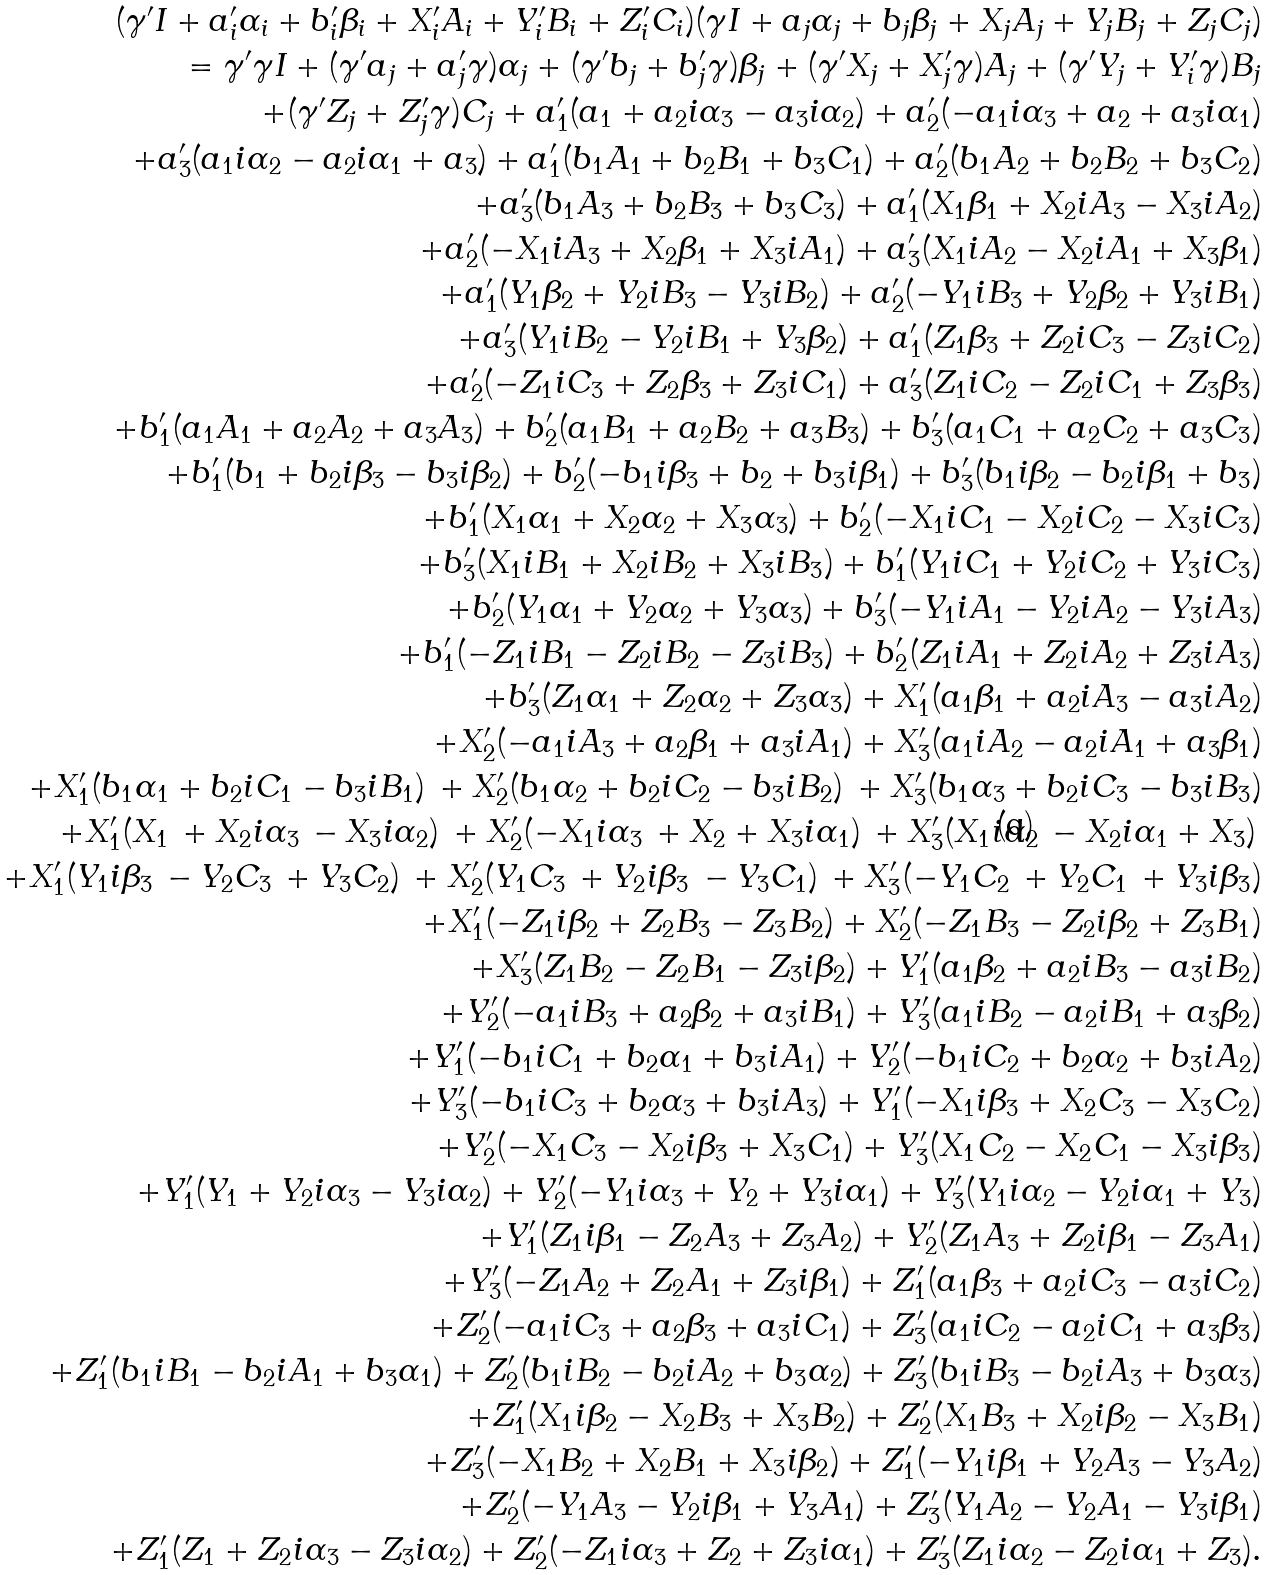Convert formula to latex. <formula><loc_0><loc_0><loc_500><loc_500>( \gamma ^ { \prime } I + a _ { i } ^ { \prime } \alpha _ { i } + b _ { i } ^ { \prime } \beta _ { i } + X _ { i } ^ { \prime } A _ { i } + Y _ { i } ^ { \prime } B _ { i } + Z _ { i } ^ { \prime } C _ { i } ) ( \gamma I + a _ { j } \alpha _ { j } + b _ { j } \beta _ { j } + X _ { j } A _ { j } + Y _ { j } B _ { j } + Z _ { j } C _ { j } ) \\ = \gamma ^ { \prime } \gamma I + ( \gamma ^ { \prime } a _ { j } + a _ { j } ^ { \prime } \gamma ) \alpha _ { j } + ( \gamma ^ { \prime } b _ { j } + b _ { j } ^ { \prime } \gamma ) \beta _ { j } + ( \gamma ^ { \prime } X _ { j } + X _ { j } ^ { \prime } \gamma ) A _ { j } + ( \gamma ^ { \prime } Y _ { j } + Y _ { i } ^ { \prime } \gamma ) B _ { j } \\ + ( \gamma ^ { \prime } Z _ { j } + Z _ { j } ^ { \prime } \gamma ) C _ { j } + a _ { 1 } ^ { \prime } ( a _ { 1 } + a _ { 2 } i \alpha _ { 3 } - a _ { 3 } i \alpha _ { 2 } ) + a _ { 2 } ^ { \prime } ( - a _ { 1 } i \alpha _ { 3 } + a _ { 2 } + a _ { 3 } i \alpha _ { 1 } ) \\ + a _ { 3 } ^ { \prime } ( a _ { 1 } i \alpha _ { 2 } - a _ { 2 } i \alpha _ { 1 } + a _ { 3 } ) + a _ { 1 } ^ { \prime } ( b _ { 1 } A _ { 1 } + b _ { 2 } B _ { 1 } + b _ { 3 } C _ { 1 } ) + a _ { 2 } ^ { \prime } ( b _ { 1 } A _ { 2 } + b _ { 2 } B _ { 2 } + b _ { 3 } C _ { 2 } ) \\ + a _ { 3 } ^ { \prime } ( b _ { 1 } A _ { 3 } + b _ { 2 } B _ { 3 } + b _ { 3 } C _ { 3 } ) + a _ { 1 } ^ { \prime } ( X _ { 1 } \beta _ { 1 } + X _ { 2 } i A _ { 3 } - X _ { 3 } i A _ { 2 } ) \\ + a _ { 2 } ^ { \prime } ( - X _ { 1 } i A _ { 3 } + X _ { 2 } \beta _ { 1 } + X _ { 3 } i A _ { 1 } ) + a _ { 3 } ^ { \prime } ( X _ { 1 } i A _ { 2 } - X _ { 2 } i A _ { 1 } + X _ { 3 } \beta _ { 1 } ) \\ + a _ { 1 } ^ { \prime } ( Y _ { 1 } \beta _ { 2 } + Y _ { 2 } i B _ { 3 } - Y _ { 3 } i B _ { 2 } ) + a _ { 2 } ^ { \prime } ( - Y _ { 1 } i B _ { 3 } + Y _ { 2 } \beta _ { 2 } + Y _ { 3 } i B _ { 1 } ) \\ + a _ { 3 } ^ { \prime } ( Y _ { 1 } i B _ { 2 } - Y _ { 2 } i B _ { 1 } + Y _ { 3 } \beta _ { 2 } ) + a _ { 1 } ^ { \prime } ( Z _ { 1 } \beta _ { 3 } + Z _ { 2 } i C _ { 3 } - Z _ { 3 } i C _ { 2 } ) \\ + a _ { 2 } ^ { \prime } ( - Z _ { 1 } i C _ { 3 } + Z _ { 2 } \beta _ { 3 } + Z _ { 3 } i C _ { 1 } ) + a _ { 3 } ^ { \prime } ( Z _ { 1 } i C _ { 2 } - Z _ { 2 } i C _ { 1 } + Z _ { 3 } \beta _ { 3 } ) \\ + b _ { 1 } ^ { \prime } ( a _ { 1 } A _ { 1 } + a _ { 2 } A _ { 2 } + a _ { 3 } A _ { 3 } ) + b _ { 2 } ^ { \prime } ( a _ { 1 } B _ { 1 } + a _ { 2 } B _ { 2 } + a _ { 3 } B _ { 3 } ) + b _ { 3 } ^ { \prime } ( a _ { 1 } C _ { 1 } + a _ { 2 } C _ { 2 } + a _ { 3 } C _ { 3 } ) \\ + b _ { 1 } ^ { \prime } ( b _ { 1 } + b _ { 2 } i \beta _ { 3 } - b _ { 3 } i \beta _ { 2 } ) + b _ { 2 } ^ { \prime } ( - b _ { 1 } i \beta _ { 3 } + b _ { 2 } + b _ { 3 } i \beta _ { 1 } ) + b _ { 3 } ^ { \prime } ( b _ { 1 } i \beta _ { 2 } - b _ { 2 } i \beta _ { 1 } + b _ { 3 } ) \\ + b _ { 1 } ^ { \prime } ( X _ { 1 } \alpha _ { 1 } + X _ { 2 } \alpha _ { 2 } + X _ { 3 } \alpha _ { 3 } ) + b _ { 2 } ^ { \prime } ( - X _ { 1 } i C _ { 1 } - X _ { 2 } i C _ { 2 } - X _ { 3 } i C _ { 3 } ) \\ + b _ { 3 } ^ { \prime } ( X _ { 1 } i B _ { 1 } + X _ { 2 } i B _ { 2 } + X _ { 3 } i B _ { 3 } ) + b _ { 1 } ^ { \prime } ( Y _ { 1 } i C _ { 1 } + Y _ { 2 } i C _ { 2 } + Y _ { 3 } i C _ { 3 } ) \\ + b _ { 2 } ^ { \prime } ( Y _ { 1 } \alpha _ { 1 } + Y _ { 2 } \alpha _ { 2 } + Y _ { 3 } \alpha _ { 3 } ) + b _ { 3 } ^ { \prime } ( - Y _ { 1 } i A _ { 1 } - Y _ { 2 } i A _ { 2 } - Y _ { 3 } i A _ { 3 } ) \\ + b _ { 1 } ^ { \prime } ( - Z _ { 1 } i B _ { 1 } - Z _ { 2 } i B _ { 2 } - Z _ { 3 } i B _ { 3 } ) + b _ { 2 } ^ { \prime } ( Z _ { 1 } i A _ { 1 } + Z _ { 2 } i A _ { 2 } + Z _ { 3 } i A _ { 3 } ) \\ + b _ { 3 } ^ { \prime } ( Z _ { 1 } \alpha _ { 1 } + Z _ { 2 } \alpha _ { 2 } + Z _ { 3 } \alpha _ { 3 } ) + X _ { 1 } ^ { \prime } ( a _ { 1 } \beta _ { 1 } + a _ { 2 } i A _ { 3 } - a _ { 3 } i A _ { 2 } ) \\ + X _ { 2 } ^ { \prime } ( - a _ { 1 } i A _ { 3 } + a _ { 2 } \beta _ { 1 } + a _ { 3 } i A _ { 1 } ) + X _ { 3 } ^ { \prime } ( a _ { 1 } i A _ { 2 } - a _ { 2 } i A _ { 1 } + a _ { 3 } \beta _ { 1 } ) \\ + X _ { 1 } ^ { \prime } ( b _ { 1 } \alpha _ { 1 } + b _ { 2 } i C _ { 1 } - b _ { 3 } i B _ { 1 } ) \, + X _ { 2 } ^ { \prime } ( b _ { 1 } \alpha _ { 2 } + b _ { 2 } i C _ { 2 } - b _ { 3 } i B _ { 2 } ) \, + X _ { 3 } ^ { \prime } ( b _ { 1 } \alpha _ { 3 } + b _ { 2 } i C _ { 3 } - b _ { 3 } i B _ { 3 } ) \\ + X _ { 1 } ^ { \prime } ( X _ { 1 } \, + X _ { 2 } i \alpha _ { 3 } \, - X _ { 3 } i \alpha _ { 2 } ) \, + X _ { 2 } ^ { \prime } ( - X _ { 1 } i \alpha _ { 3 } \, + X _ { 2 } + X _ { 3 } i \alpha _ { 1 } ) \, + X _ { 3 } ^ { \prime } ( X _ { 1 } i \alpha _ { 2 } \, - X _ { 2 } i \alpha _ { 1 } + X _ { 3 } ) \, \\ + X _ { 1 } ^ { \prime } ( Y _ { 1 } i \beta _ { 3 } \, - Y _ { 2 } C _ { 3 } \, + Y _ { 3 } C _ { 2 } ) \, + X _ { 2 } ^ { \prime } ( Y _ { 1 } C _ { 3 } \, + Y _ { 2 } i \beta _ { 3 } \, - Y _ { 3 } C _ { 1 } ) \, + X _ { 3 } ^ { \prime } ( - Y _ { 1 } C _ { 2 } \, + Y _ { 2 } C _ { 1 } \, + Y _ { 3 } i \beta _ { 3 } ) \\ + X _ { 1 } ^ { \prime } ( - Z _ { 1 } i \beta _ { 2 } + Z _ { 2 } B _ { 3 } - Z _ { 3 } B _ { 2 } ) + X _ { 2 } ^ { \prime } ( - Z _ { 1 } B _ { 3 } - Z _ { 2 } i \beta _ { 2 } + Z _ { 3 } B _ { 1 } ) \\ + X _ { 3 } ^ { \prime } ( Z _ { 1 } B _ { 2 } - Z _ { 2 } B _ { 1 } - Z _ { 3 } i \beta _ { 2 } ) + Y _ { 1 } ^ { \prime } ( a _ { 1 } \beta _ { 2 } + a _ { 2 } i B _ { 3 } - a _ { 3 } i B _ { 2 } ) \\ + Y _ { 2 } ^ { \prime } ( - a _ { 1 } i B _ { 3 } + a _ { 2 } \beta _ { 2 } + a _ { 3 } i B _ { 1 } ) + Y _ { 3 } ^ { \prime } ( a _ { 1 } i B _ { 2 } - a _ { 2 } i B _ { 1 } + a _ { 3 } \beta _ { 2 } ) \\ + Y _ { 1 } ^ { \prime } ( - b _ { 1 } i C _ { 1 } + b _ { 2 } \alpha _ { 1 } + b _ { 3 } i A _ { 1 } ) + Y _ { 2 } ^ { \prime } ( - b _ { 1 } i C _ { 2 } + b _ { 2 } \alpha _ { 2 } + b _ { 3 } i A _ { 2 } ) \\ + Y _ { 3 } ^ { \prime } ( - b _ { 1 } i C _ { 3 } + b _ { 2 } \alpha _ { 3 } + b _ { 3 } i A _ { 3 } ) + Y _ { 1 } ^ { \prime } ( - X _ { 1 } i \beta _ { 3 } + X _ { 2 } C _ { 3 } - X _ { 3 } C _ { 2 } ) \\ + Y _ { 2 } ^ { \prime } ( - X _ { 1 } C _ { 3 } - X _ { 2 } i \beta _ { 3 } + X _ { 3 } C _ { 1 } ) + Y _ { 3 } ^ { \prime } ( X _ { 1 } C _ { 2 } - X _ { 2 } C _ { 1 } - X _ { 3 } i \beta _ { 3 } ) \\ + Y _ { 1 } ^ { \prime } ( Y _ { 1 } + Y _ { 2 } i \alpha _ { 3 } - Y _ { 3 } i \alpha _ { 2 } ) + Y _ { 2 } ^ { \prime } ( - Y _ { 1 } i \alpha _ { 3 } + Y _ { 2 } + Y _ { 3 } i \alpha _ { 1 } ) + Y _ { 3 } ^ { \prime } ( Y _ { 1 } i \alpha _ { 2 } - Y _ { 2 } i \alpha _ { 1 } + Y _ { 3 } ) \\ + Y _ { 1 } ^ { \prime } ( Z _ { 1 } i \beta _ { 1 } - Z _ { 2 } A _ { 3 } + Z _ { 3 } A _ { 2 } ) + Y _ { 2 } ^ { \prime } ( Z _ { 1 } A _ { 3 } + Z _ { 2 } i \beta _ { 1 } - Z _ { 3 } A _ { 1 } ) \\ + Y _ { 3 } ^ { \prime } ( - Z _ { 1 } A _ { 2 } + Z _ { 2 } A _ { 1 } + Z _ { 3 } i \beta _ { 1 } ) + Z _ { 1 } ^ { \prime } ( a _ { 1 } \beta _ { 3 } + a _ { 2 } i C _ { 3 } - a _ { 3 } i C _ { 2 } ) \\ + Z _ { 2 } ^ { \prime } ( - a _ { 1 } i C _ { 3 } + a _ { 2 } \beta _ { 3 } + a _ { 3 } i C _ { 1 } ) + Z _ { 3 } ^ { \prime } ( a _ { 1 } i C _ { 2 } - a _ { 2 } i C _ { 1 } + a _ { 3 } \beta _ { 3 } ) \\ + Z _ { 1 } ^ { \prime } ( b _ { 1 } i B _ { 1 } - b _ { 2 } i A _ { 1 } + b _ { 3 } \alpha _ { 1 } ) + Z _ { 2 } ^ { \prime } ( b _ { 1 } i B _ { 2 } - b _ { 2 } i A _ { 2 } + b _ { 3 } \alpha _ { 2 } ) + Z _ { 3 } ^ { \prime } ( b _ { 1 } i B _ { 3 } - b _ { 2 } i A _ { 3 } + b _ { 3 } \alpha _ { 3 } ) \\ + Z _ { 1 } ^ { \prime } ( X _ { 1 } i \beta _ { 2 } - X _ { 2 } B _ { 3 } + X _ { 3 } B _ { 2 } ) + Z _ { 2 } ^ { \prime } ( X _ { 1 } B _ { 3 } + X _ { 2 } i \beta _ { 2 } - X _ { 3 } B _ { 1 } ) \\ + Z _ { 3 } ^ { \prime } ( - X _ { 1 } B _ { 2 } + X _ { 2 } B _ { 1 } + X _ { 3 } i \beta _ { 2 } ) + Z _ { 1 } ^ { \prime } ( - Y _ { 1 } i \beta _ { 1 } + Y _ { 2 } A _ { 3 } - Y _ { 3 } A _ { 2 } ) \\ + Z _ { 2 } ^ { \prime } ( - Y _ { 1 } A _ { 3 } - Y _ { 2 } i \beta _ { 1 } + Y _ { 3 } A _ { 1 } ) + Z _ { 3 } ^ { \prime } ( Y _ { 1 } A _ { 2 } - Y _ { 2 } A _ { 1 } - Y _ { 3 } i \beta _ { 1 } ) \\ + Z _ { 1 } ^ { \prime } ( Z _ { 1 } + Z _ { 2 } i \alpha _ { 3 } - Z _ { 3 } i \alpha _ { 2 } ) + Z _ { 2 } ^ { \prime } ( - Z _ { 1 } i \alpha _ { 3 } + Z _ { 2 } + Z _ { 3 } i \alpha _ { 1 } ) + Z _ { 3 } ^ { \prime } ( Z _ { 1 } i \alpha _ { 2 } - Z _ { 2 } i \alpha _ { 1 } + Z _ { 3 } ) .</formula> 